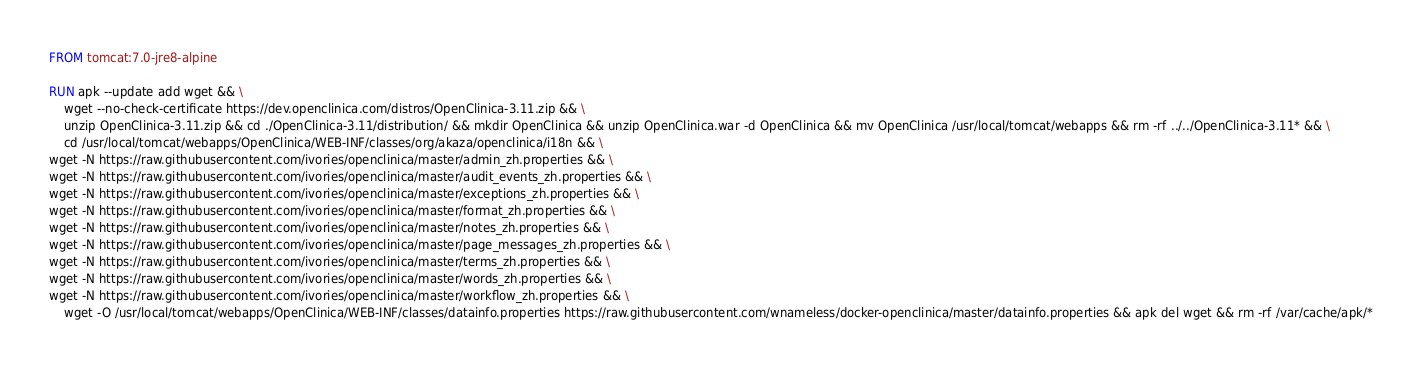Convert code to text. <code><loc_0><loc_0><loc_500><loc_500><_Dockerfile_>FROM tomcat:7.0-jre8-alpine

RUN apk --update add wget && \
    wget --no-check-certificate https://dev.openclinica.com/distros/OpenClinica-3.11.zip && \
    unzip OpenClinica-3.11.zip && cd ./OpenClinica-3.11/distribution/ && mkdir OpenClinica && unzip OpenClinica.war -d OpenClinica && mv OpenClinica /usr/local/tomcat/webapps && rm -rf ../../OpenClinica-3.11* && \
    cd /usr/local/tomcat/webapps/OpenClinica/WEB-INF/classes/org/akaza/openclinica/i18n && \
wget -N https://raw.githubusercontent.com/ivories/openclinica/master/admin_zh.properties && \
wget -N https://raw.githubusercontent.com/ivories/openclinica/master/audit_events_zh.properties && \
wget -N https://raw.githubusercontent.com/ivories/openclinica/master/exceptions_zh.properties && \
wget -N https://raw.githubusercontent.com/ivories/openclinica/master/format_zh.properties && \
wget -N https://raw.githubusercontent.com/ivories/openclinica/master/notes_zh.properties && \
wget -N https://raw.githubusercontent.com/ivories/openclinica/master/page_messages_zh.properties && \
wget -N https://raw.githubusercontent.com/ivories/openclinica/master/terms_zh.properties && \
wget -N https://raw.githubusercontent.com/ivories/openclinica/master/words_zh.properties && \
wget -N https://raw.githubusercontent.com/ivories/openclinica/master/workflow_zh.properties && \ 
    wget -O /usr/local/tomcat/webapps/OpenClinica/WEB-INF/classes/datainfo.properties https://raw.githubusercontent.com/wnameless/docker-openclinica/master/datainfo.properties && apk del wget && rm -rf /var/cache/apk/* 

</code> 